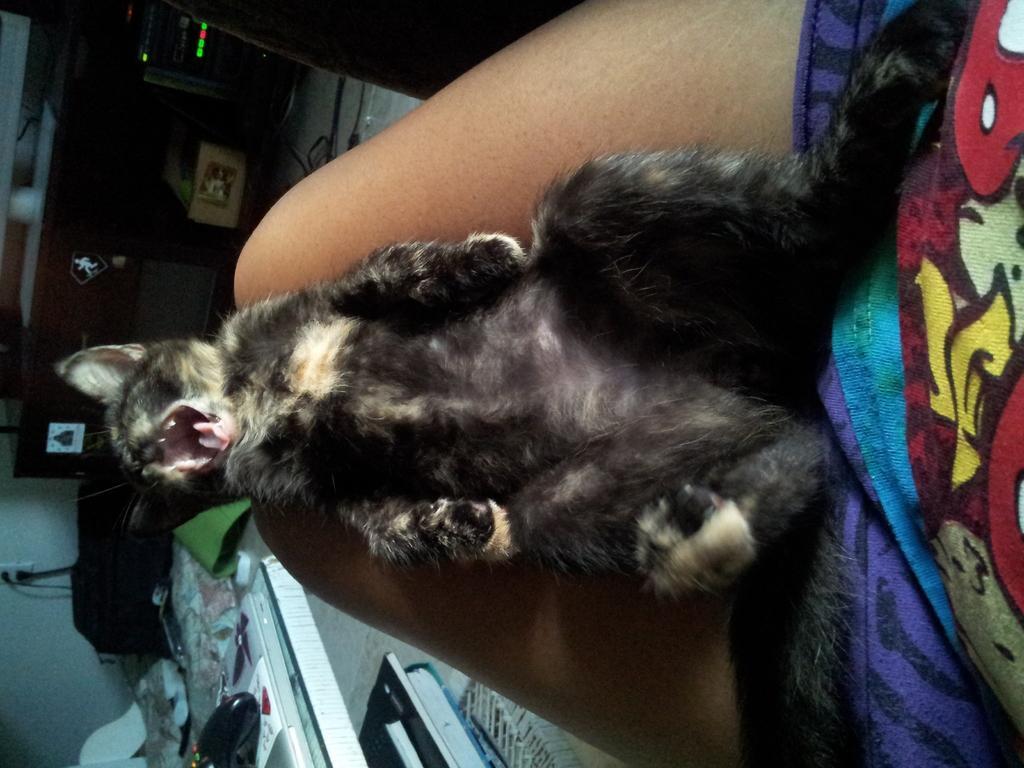Describe this image in one or two sentences. There is a cat lying on the lap of a person. In the background there are books, table, socket and many other items. 